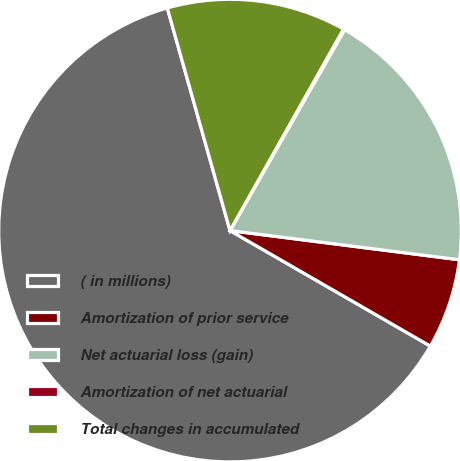Convert chart to OTSL. <chart><loc_0><loc_0><loc_500><loc_500><pie_chart><fcel>( in millions)<fcel>Amortization of prior service<fcel>Net actuarial loss (gain)<fcel>Amortization of net actuarial<fcel>Total changes in accumulated<nl><fcel>62.3%<fcel>6.31%<fcel>18.76%<fcel>0.09%<fcel>12.53%<nl></chart> 